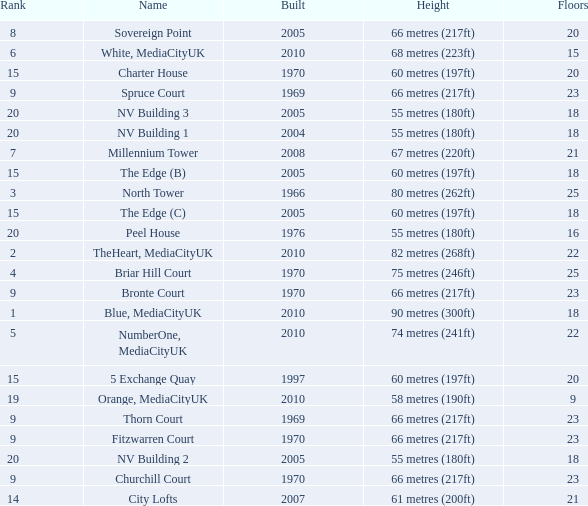What is the lowest Floors, when Built is greater than 1970, and when Name is NV Building 3? 18.0. Parse the full table. {'header': ['Rank', 'Name', 'Built', 'Height', 'Floors'], 'rows': [['8', 'Sovereign Point', '2005', '66 metres (217ft)', '20'], ['6', 'White, MediaCityUK', '2010', '68 metres (223ft)', '15'], ['15', 'Charter House', '1970', '60 metres (197ft)', '20'], ['9', 'Spruce Court', '1969', '66 metres (217ft)', '23'], ['20', 'NV Building 3', '2005', '55 metres (180ft)', '18'], ['20', 'NV Building 1', '2004', '55 metres (180ft)', '18'], ['7', 'Millennium Tower', '2008', '67 metres (220ft)', '21'], ['15', 'The Edge (B)', '2005', '60 metres (197ft)', '18'], ['3', 'North Tower', '1966', '80 metres (262ft)', '25'], ['15', 'The Edge (C)', '2005', '60 metres (197ft)', '18'], ['20', 'Peel House', '1976', '55 metres (180ft)', '16'], ['2', 'TheHeart, MediaCityUK', '2010', '82 metres (268ft)', '22'], ['4', 'Briar Hill Court', '1970', '75 metres (246ft)', '25'], ['9', 'Bronte Court', '1970', '66 metres (217ft)', '23'], ['1', 'Blue, MediaCityUK', '2010', '90 metres (300ft)', '18'], ['5', 'NumberOne, MediaCityUK', '2010', '74 metres (241ft)', '22'], ['15', '5 Exchange Quay', '1997', '60 metres (197ft)', '20'], ['19', 'Orange, MediaCityUK', '2010', '58 metres (190ft)', '9'], ['9', 'Thorn Court', '1969', '66 metres (217ft)', '23'], ['9', 'Fitzwarren Court', '1970', '66 metres (217ft)', '23'], ['20', 'NV Building 2', '2005', '55 metres (180ft)', '18'], ['9', 'Churchill Court', '1970', '66 metres (217ft)', '23'], ['14', 'City Lofts', '2007', '61 metres (200ft)', '21']]} 